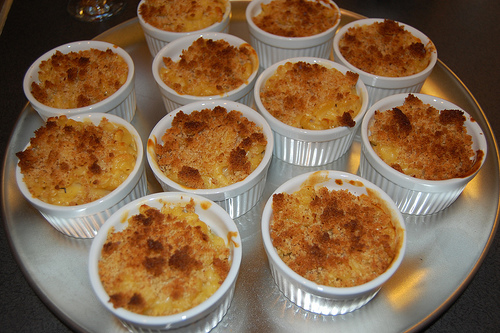<image>
Is the food on the table? Yes. Looking at the image, I can see the food is positioned on top of the table, with the table providing support. Is there a cake to the left of the cake? Yes. From this viewpoint, the cake is positioned to the left side relative to the cake. 